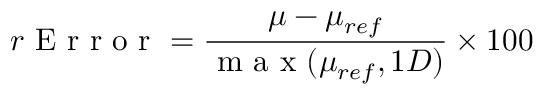<formula> <loc_0><loc_0><loc_500><loc_500>r E r r o r = \frac { \mu - \mu _ { r e f } } { m a x ( \mu _ { r e f } , 1 D ) } \times 1 0 0 \</formula> 